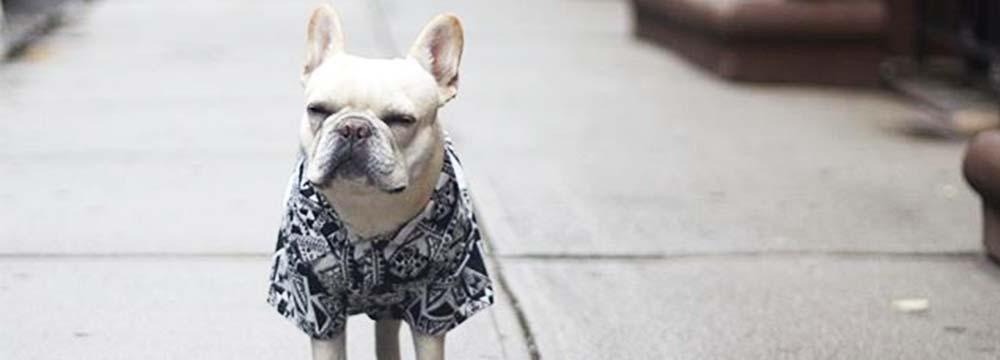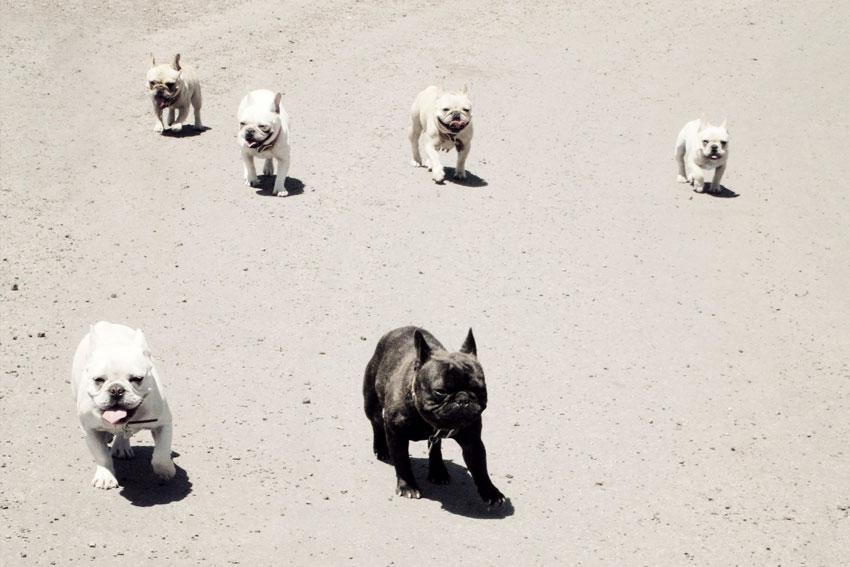The first image is the image on the left, the second image is the image on the right. For the images shown, is this caption "A total of seven dog figures are shown." true? Answer yes or no. Yes. The first image is the image on the left, the second image is the image on the right. Analyze the images presented: Is the assertion "There are at least two living breathing Bulldogs looking forward." valid? Answer yes or no. Yes. 